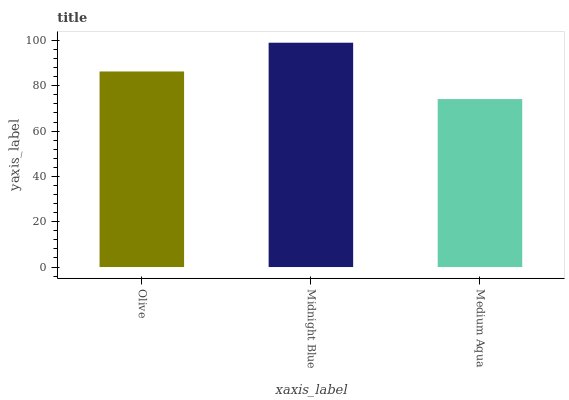Is Medium Aqua the minimum?
Answer yes or no. Yes. Is Midnight Blue the maximum?
Answer yes or no. Yes. Is Midnight Blue the minimum?
Answer yes or no. No. Is Medium Aqua the maximum?
Answer yes or no. No. Is Midnight Blue greater than Medium Aqua?
Answer yes or no. Yes. Is Medium Aqua less than Midnight Blue?
Answer yes or no. Yes. Is Medium Aqua greater than Midnight Blue?
Answer yes or no. No. Is Midnight Blue less than Medium Aqua?
Answer yes or no. No. Is Olive the high median?
Answer yes or no. Yes. Is Olive the low median?
Answer yes or no. Yes. Is Medium Aqua the high median?
Answer yes or no. No. Is Midnight Blue the low median?
Answer yes or no. No. 